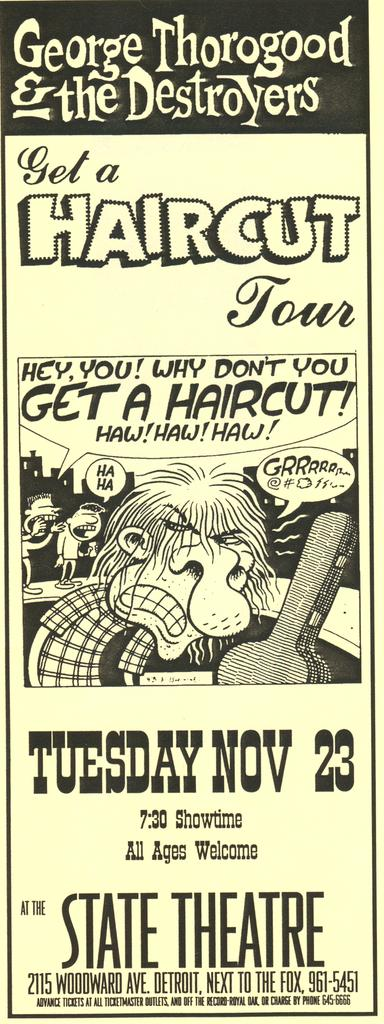<image>
Present a compact description of the photo's key features. a ticket to the state theatre for November 23rd 